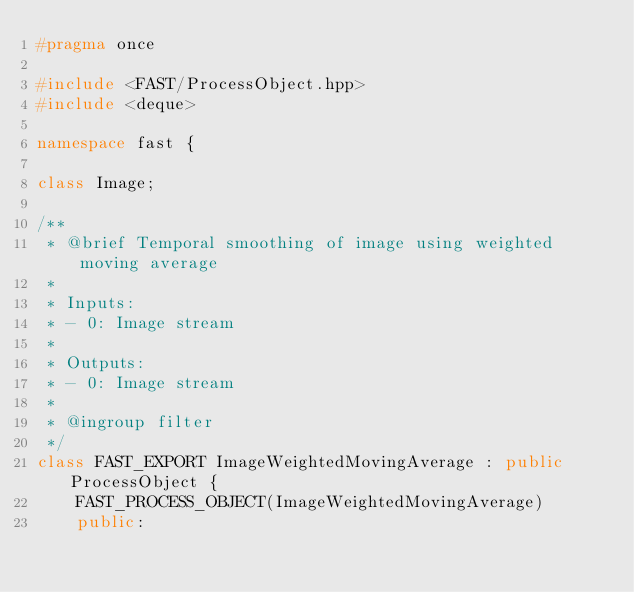Convert code to text. <code><loc_0><loc_0><loc_500><loc_500><_C++_>#pragma once

#include <FAST/ProcessObject.hpp>
#include <deque>

namespace fast {

class Image;

/**
 * @brief Temporal smoothing of image using weighted moving average
 *
 * Inputs:
 * - 0: Image stream
 *
 * Outputs:
 * - 0: Image stream
 *
 * @ingroup filter
 */
class FAST_EXPORT ImageWeightedMovingAverage : public ProcessObject {
    FAST_PROCESS_OBJECT(ImageWeightedMovingAverage)
    public:</code> 